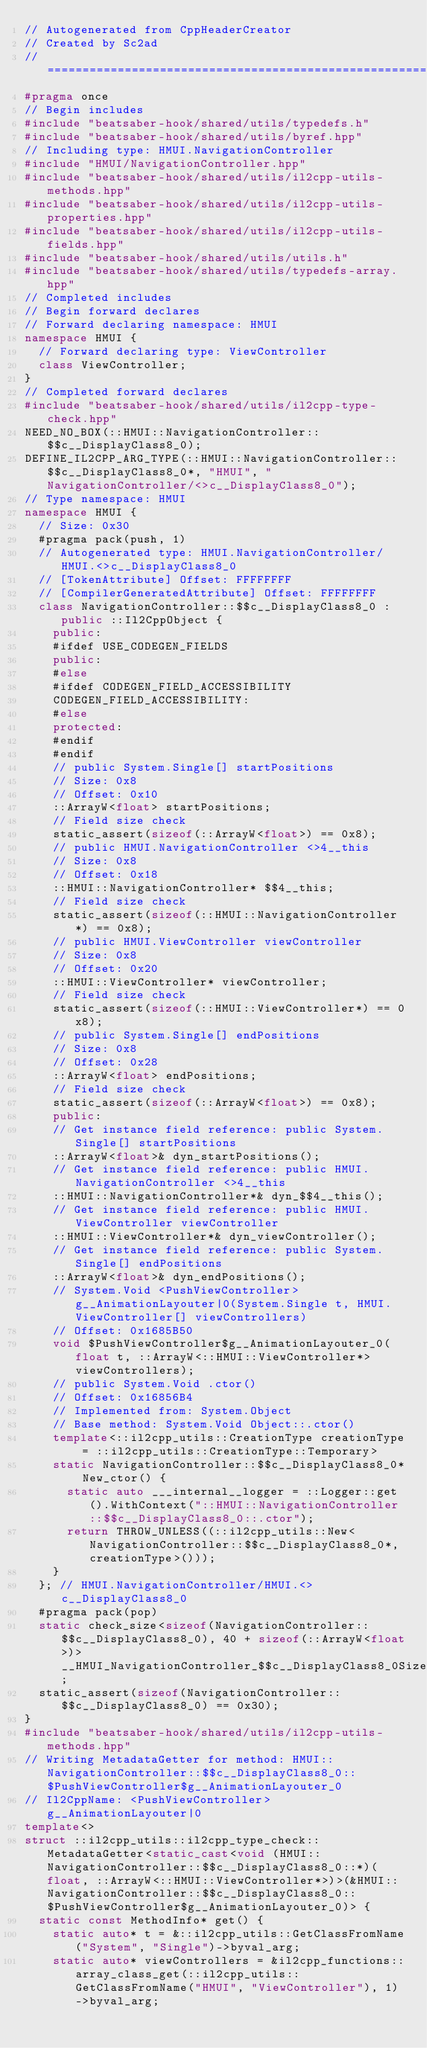<code> <loc_0><loc_0><loc_500><loc_500><_C++_>// Autogenerated from CppHeaderCreator
// Created by Sc2ad
// =========================================================================
#pragma once
// Begin includes
#include "beatsaber-hook/shared/utils/typedefs.h"
#include "beatsaber-hook/shared/utils/byref.hpp"
// Including type: HMUI.NavigationController
#include "HMUI/NavigationController.hpp"
#include "beatsaber-hook/shared/utils/il2cpp-utils-methods.hpp"
#include "beatsaber-hook/shared/utils/il2cpp-utils-properties.hpp"
#include "beatsaber-hook/shared/utils/il2cpp-utils-fields.hpp"
#include "beatsaber-hook/shared/utils/utils.h"
#include "beatsaber-hook/shared/utils/typedefs-array.hpp"
// Completed includes
// Begin forward declares
// Forward declaring namespace: HMUI
namespace HMUI {
  // Forward declaring type: ViewController
  class ViewController;
}
// Completed forward declares
#include "beatsaber-hook/shared/utils/il2cpp-type-check.hpp"
NEED_NO_BOX(::HMUI::NavigationController::$$c__DisplayClass8_0);
DEFINE_IL2CPP_ARG_TYPE(::HMUI::NavigationController::$$c__DisplayClass8_0*, "HMUI", "NavigationController/<>c__DisplayClass8_0");
// Type namespace: HMUI
namespace HMUI {
  // Size: 0x30
  #pragma pack(push, 1)
  // Autogenerated type: HMUI.NavigationController/HMUI.<>c__DisplayClass8_0
  // [TokenAttribute] Offset: FFFFFFFF
  // [CompilerGeneratedAttribute] Offset: FFFFFFFF
  class NavigationController::$$c__DisplayClass8_0 : public ::Il2CppObject {
    public:
    #ifdef USE_CODEGEN_FIELDS
    public:
    #else
    #ifdef CODEGEN_FIELD_ACCESSIBILITY
    CODEGEN_FIELD_ACCESSIBILITY:
    #else
    protected:
    #endif
    #endif
    // public System.Single[] startPositions
    // Size: 0x8
    // Offset: 0x10
    ::ArrayW<float> startPositions;
    // Field size check
    static_assert(sizeof(::ArrayW<float>) == 0x8);
    // public HMUI.NavigationController <>4__this
    // Size: 0x8
    // Offset: 0x18
    ::HMUI::NavigationController* $$4__this;
    // Field size check
    static_assert(sizeof(::HMUI::NavigationController*) == 0x8);
    // public HMUI.ViewController viewController
    // Size: 0x8
    // Offset: 0x20
    ::HMUI::ViewController* viewController;
    // Field size check
    static_assert(sizeof(::HMUI::ViewController*) == 0x8);
    // public System.Single[] endPositions
    // Size: 0x8
    // Offset: 0x28
    ::ArrayW<float> endPositions;
    // Field size check
    static_assert(sizeof(::ArrayW<float>) == 0x8);
    public:
    // Get instance field reference: public System.Single[] startPositions
    ::ArrayW<float>& dyn_startPositions();
    // Get instance field reference: public HMUI.NavigationController <>4__this
    ::HMUI::NavigationController*& dyn_$$4__this();
    // Get instance field reference: public HMUI.ViewController viewController
    ::HMUI::ViewController*& dyn_viewController();
    // Get instance field reference: public System.Single[] endPositions
    ::ArrayW<float>& dyn_endPositions();
    // System.Void <PushViewController>g__AnimationLayouter|0(System.Single t, HMUI.ViewController[] viewControllers)
    // Offset: 0x1685B50
    void $PushViewController$g__AnimationLayouter_0(float t, ::ArrayW<::HMUI::ViewController*> viewControllers);
    // public System.Void .ctor()
    // Offset: 0x16856B4
    // Implemented from: System.Object
    // Base method: System.Void Object::.ctor()
    template<::il2cpp_utils::CreationType creationType = ::il2cpp_utils::CreationType::Temporary>
    static NavigationController::$$c__DisplayClass8_0* New_ctor() {
      static auto ___internal__logger = ::Logger::get().WithContext("::HMUI::NavigationController::$$c__DisplayClass8_0::.ctor");
      return THROW_UNLESS((::il2cpp_utils::New<NavigationController::$$c__DisplayClass8_0*, creationType>()));
    }
  }; // HMUI.NavigationController/HMUI.<>c__DisplayClass8_0
  #pragma pack(pop)
  static check_size<sizeof(NavigationController::$$c__DisplayClass8_0), 40 + sizeof(::ArrayW<float>)> __HMUI_NavigationController_$$c__DisplayClass8_0SizeCheck;
  static_assert(sizeof(NavigationController::$$c__DisplayClass8_0) == 0x30);
}
#include "beatsaber-hook/shared/utils/il2cpp-utils-methods.hpp"
// Writing MetadataGetter for method: HMUI::NavigationController::$$c__DisplayClass8_0::$PushViewController$g__AnimationLayouter_0
// Il2CppName: <PushViewController>g__AnimationLayouter|0
template<>
struct ::il2cpp_utils::il2cpp_type_check::MetadataGetter<static_cast<void (HMUI::NavigationController::$$c__DisplayClass8_0::*)(float, ::ArrayW<::HMUI::ViewController*>)>(&HMUI::NavigationController::$$c__DisplayClass8_0::$PushViewController$g__AnimationLayouter_0)> {
  static const MethodInfo* get() {
    static auto* t = &::il2cpp_utils::GetClassFromName("System", "Single")->byval_arg;
    static auto* viewControllers = &il2cpp_functions::array_class_get(::il2cpp_utils::GetClassFromName("HMUI", "ViewController"), 1)->byval_arg;</code> 